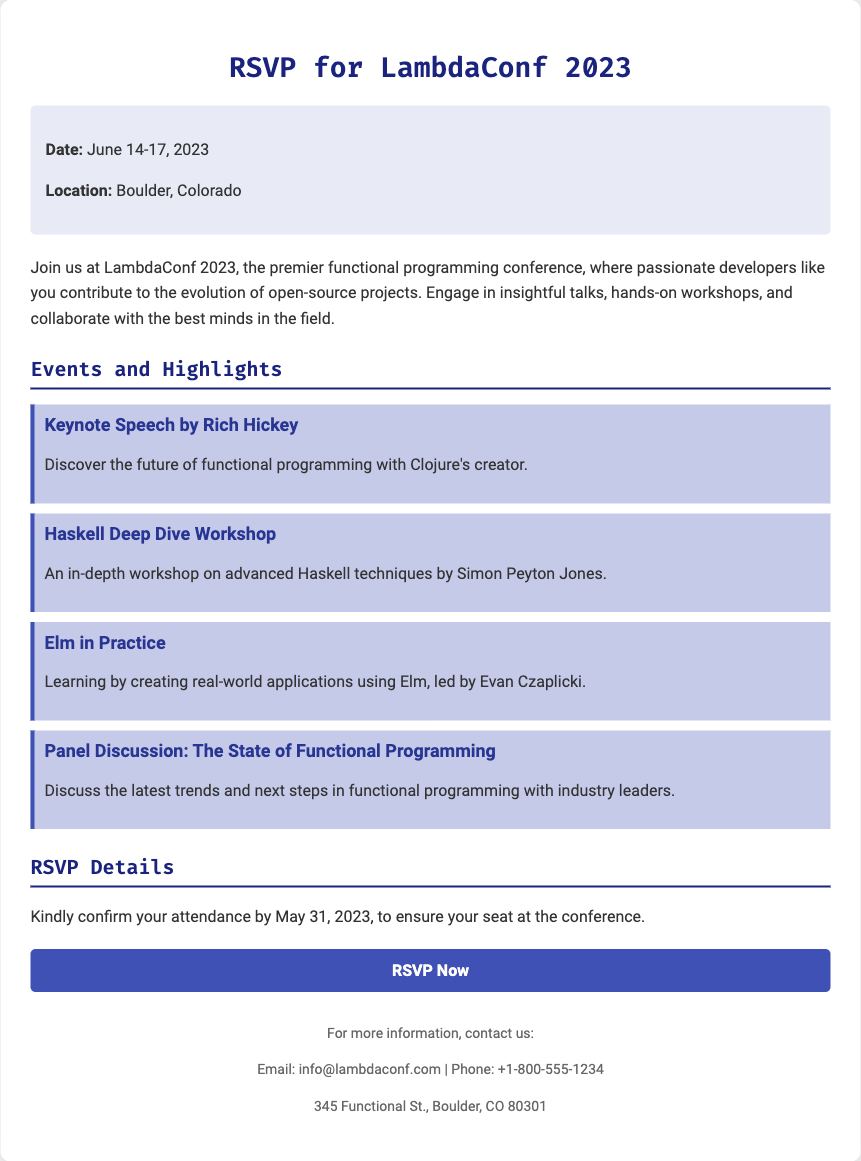what is the date of LambdaConf 2023? The date of the conference is explicitly mentioned in the document.
Answer: June 14-17, 2023 where is LambdaConf 2023 located? The location of the conference is stated in the event information section of the document.
Answer: Boulder, Colorado who is the keynote speaker? The document specifies who will deliver the keynote speech.
Answer: Rich Hickey what is the RSVP deadline? The deadline for confirming attendance is clearly mentioned in the RSVP details section.
Answer: May 31, 2023 what type of workshop will be held by Simon Peyton Jones? The document lists specific workshops including the one led by Simon Peyton Jones.
Answer: Haskell Deep Dive Workshop how many events are highlighted in the document? By counting the highlighted events listed, we can determine the total.
Answer: Four what should attendees do to secure their seat? The document advises attendees on how to confirm their attendance.
Answer: RSVP what is the email contact provided for more information? The document includes contact information for inquiries, including an email address.
Answer: info@lambdaconf.com 